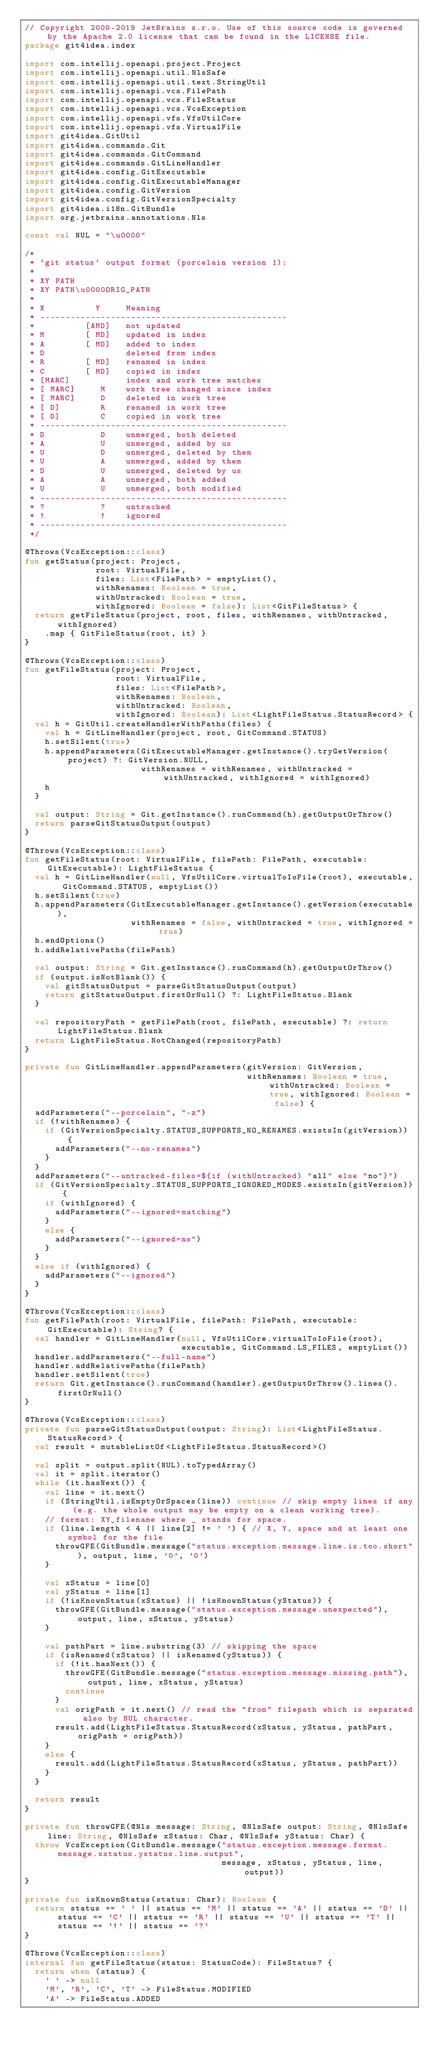<code> <loc_0><loc_0><loc_500><loc_500><_Kotlin_>// Copyright 2000-2019 JetBrains s.r.o. Use of this source code is governed by the Apache 2.0 license that can be found in the LICENSE file.
package git4idea.index

import com.intellij.openapi.project.Project
import com.intellij.openapi.util.NlsSafe
import com.intellij.openapi.util.text.StringUtil
import com.intellij.openapi.vcs.FilePath
import com.intellij.openapi.vcs.FileStatus
import com.intellij.openapi.vcs.VcsException
import com.intellij.openapi.vfs.VfsUtilCore
import com.intellij.openapi.vfs.VirtualFile
import git4idea.GitUtil
import git4idea.commands.Git
import git4idea.commands.GitCommand
import git4idea.commands.GitLineHandler
import git4idea.config.GitExecutable
import git4idea.config.GitExecutableManager
import git4idea.config.GitVersion
import git4idea.config.GitVersionSpecialty
import git4idea.i18n.GitBundle
import org.jetbrains.annotations.Nls

const val NUL = "\u0000"

/*
 * `git status` output format (porcelain version 1):
 *
 * XY PATH
 * XY PATH\u0000ORIG_PATH
 *
 * X          Y     Meaning
 * -------------------------------------------------
 * 	        [AMD]   not updated
 * M        [ MD]   updated in index
 * A        [ MD]   added to index
 * D                deleted from index
 * R        [ MD]   renamed in index
 * C        [ MD]   copied in index
 * [MARC]           index and work tree matches
 * [ MARC]     M    work tree changed since index
 * [ MARC]     D    deleted in work tree
 * [ D]        R    renamed in work tree
 * [ D]        C    copied in work tree
 * -------------------------------------------------
 * D           D    unmerged, both deleted
 * A           U    unmerged, added by us
 * U           D    unmerged, deleted by them
 * U           A    unmerged, added by them
 * D           U    unmerged, deleted by us
 * A           A    unmerged, both added
 * U           U    unmerged, both modified
 * -------------------------------------------------
 * ?           ?    untracked
 * !           !    ignored
 * -------------------------------------------------
 */

@Throws(VcsException::class)
fun getStatus(project: Project,
              root: VirtualFile,
              files: List<FilePath> = emptyList(),
              withRenames: Boolean = true,
              withUntracked: Boolean = true,
              withIgnored: Boolean = false): List<GitFileStatus> {
  return getFileStatus(project, root, files, withRenames, withUntracked, withIgnored)
    .map { GitFileStatus(root, it) }
}

@Throws(VcsException::class)
fun getFileStatus(project: Project,
                  root: VirtualFile,
                  files: List<FilePath>,
                  withRenames: Boolean,
                  withUntracked: Boolean,
                  withIgnored: Boolean): List<LightFileStatus.StatusRecord> {
  val h = GitUtil.createHandlerWithPaths(files) {
    val h = GitLineHandler(project, root, GitCommand.STATUS)
    h.setSilent(true)
    h.appendParameters(GitExecutableManager.getInstance().tryGetVersion(project) ?: GitVersion.NULL,
                       withRenames = withRenames, withUntracked = withUntracked, withIgnored = withIgnored)
    h
  }

  val output: String = Git.getInstance().runCommand(h).getOutputOrThrow()
  return parseGitStatusOutput(output)
}

@Throws(VcsException::class)
fun getFileStatus(root: VirtualFile, filePath: FilePath, executable: GitExecutable): LightFileStatus {
  val h = GitLineHandler(null, VfsUtilCore.virtualToIoFile(root), executable, GitCommand.STATUS, emptyList())
  h.setSilent(true)
  h.appendParameters(GitExecutableManager.getInstance().getVersion(executable),
                     withRenames = false, withUntracked = true, withIgnored = true)
  h.endOptions()
  h.addRelativePaths(filePath)

  val output: String = Git.getInstance().runCommand(h).getOutputOrThrow()
  if (output.isNotBlank()) {
    val gitStatusOutput = parseGitStatusOutput(output)
    return gitStatusOutput.firstOrNull() ?: LightFileStatus.Blank
  }

  val repositoryPath = getFilePath(root, filePath, executable) ?: return LightFileStatus.Blank
  return LightFileStatus.NotChanged(repositoryPath)
}

private fun GitLineHandler.appendParameters(gitVersion: GitVersion,
                                            withRenames: Boolean = true, withUntracked: Boolean = true, withIgnored: Boolean = false) {
  addParameters("--porcelain", "-z")
  if (!withRenames) {
    if (GitVersionSpecialty.STATUS_SUPPORTS_NO_RENAMES.existsIn(gitVersion)) {
      addParameters("--no-renames")
    }
  }
  addParameters("--untracked-files=${if (withUntracked) "all" else "no"}")
  if (GitVersionSpecialty.STATUS_SUPPORTS_IGNORED_MODES.existsIn(gitVersion)) {
    if (withIgnored) {
      addParameters("--ignored=matching")
    }
    else {
      addParameters("--ignored=no")
    }
  }
  else if (withIgnored) {
    addParameters("--ignored")
  }
}

@Throws(VcsException::class)
fun getFilePath(root: VirtualFile, filePath: FilePath, executable: GitExecutable): String? {
  val handler = GitLineHandler(null, VfsUtilCore.virtualToIoFile(root),
                               executable, GitCommand.LS_FILES, emptyList())
  handler.addParameters("--full-name")
  handler.addRelativePaths(filePath)
  handler.setSilent(true)
  return Git.getInstance().runCommand(handler).getOutputOrThrow().lines().firstOrNull()
}

@Throws(VcsException::class)
private fun parseGitStatusOutput(output: String): List<LightFileStatus.StatusRecord> {
  val result = mutableListOf<LightFileStatus.StatusRecord>()

  val split = output.split(NUL).toTypedArray()
  val it = split.iterator()
  while (it.hasNext()) {
    val line = it.next()
    if (StringUtil.isEmptyOrSpaces(line)) continue // skip empty lines if any (e.g. the whole output may be empty on a clean working tree).
    // format: XY_filename where _ stands for space.
    if (line.length < 4 || line[2] != ' ') { // X, Y, space and at least one symbol for the file
      throwGFE(GitBundle.message("status.exception.message.line.is.too.short"), output, line, '0', '0')
    }

    val xStatus = line[0]
    val yStatus = line[1]
    if (!isKnownStatus(xStatus) || !isKnownStatus(yStatus)) {
      throwGFE(GitBundle.message("status.exception.message.unexpected"), output, line, xStatus, yStatus)
    }

    val pathPart = line.substring(3) // skipping the space
    if (isRenamed(xStatus) || isRenamed(yStatus)) {
      if (!it.hasNext()) {
        throwGFE(GitBundle.message("status.exception.message.missing.path"), output, line, xStatus, yStatus)
        continue
      }
      val origPath = it.next() // read the "from" filepath which is separated also by NUL character.
      result.add(LightFileStatus.StatusRecord(xStatus, yStatus, pathPart, origPath = origPath))
    }
    else {
      result.add(LightFileStatus.StatusRecord(xStatus, yStatus, pathPart))
    }
  }

  return result
}

private fun throwGFE(@Nls message: String, @NlsSafe output: String, @NlsSafe line: String, @NlsSafe xStatus: Char, @NlsSafe yStatus: Char) {
  throw VcsException(GitBundle.message("status.exception.message.format.message.xstatus.ystatus.line.output",
                                       message, xStatus, yStatus, line, output))
}

private fun isKnownStatus(status: Char): Boolean {
  return status == ' ' || status == 'M' || status == 'A' || status == 'D' || status == 'C' || status == 'R' || status == 'U' || status == 'T' || status == '!' || status == '?'
}

@Throws(VcsException::class)
internal fun getFileStatus(status: StatusCode): FileStatus? {
  return when (status) {
    ' ' -> null
    'M', 'R', 'C', 'T' -> FileStatus.MODIFIED
    'A' -> FileStatus.ADDED</code> 